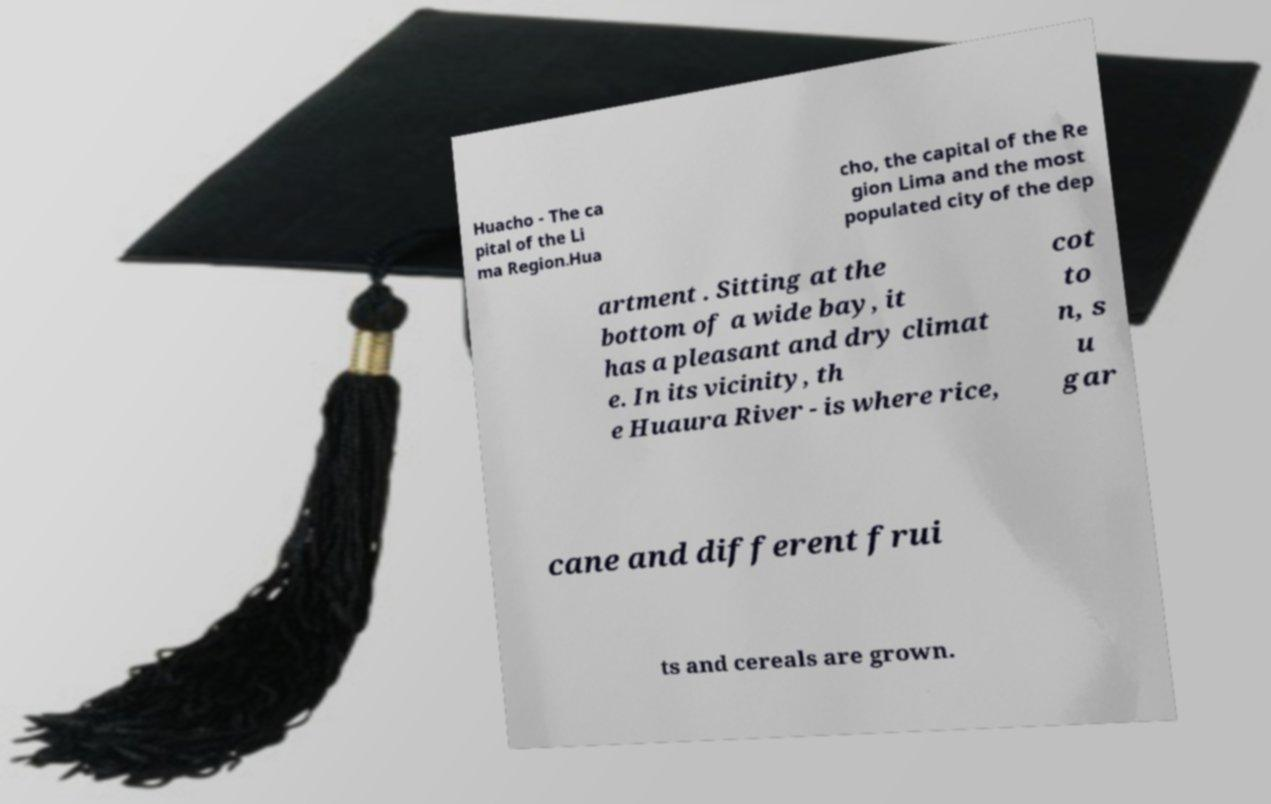Can you read and provide the text displayed in the image?This photo seems to have some interesting text. Can you extract and type it out for me? Huacho - The ca pital of the Li ma Region.Hua cho, the capital of the Re gion Lima and the most populated city of the dep artment . Sitting at the bottom of a wide bay, it has a pleasant and dry climat e. In its vicinity, th e Huaura River - is where rice, cot to n, s u gar cane and different frui ts and cereals are grown. 